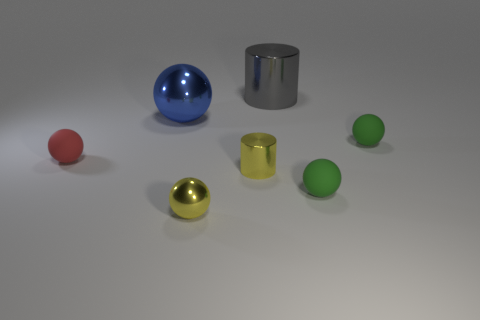Subtract all gray balls. Subtract all red blocks. How many balls are left? 5 Add 2 big green shiny cylinders. How many objects exist? 9 Subtract all spheres. How many objects are left? 2 Add 7 tiny yellow shiny cylinders. How many tiny yellow shiny cylinders are left? 8 Add 7 big gray objects. How many big gray objects exist? 8 Subtract 0 cyan cylinders. How many objects are left? 7 Subtract all metallic balls. Subtract all small cylinders. How many objects are left? 4 